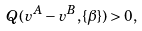<formula> <loc_0><loc_0><loc_500><loc_500>Q ( v ^ { A } - v ^ { B } , \{ \beta \} ) > 0 ,</formula> 